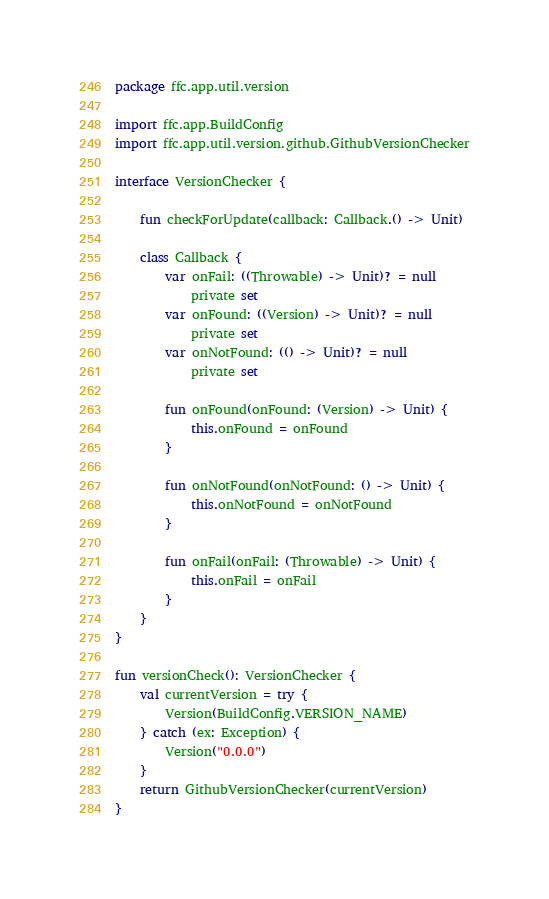<code> <loc_0><loc_0><loc_500><loc_500><_Kotlin_>package ffc.app.util.version

import ffc.app.BuildConfig
import ffc.app.util.version.github.GithubVersionChecker

interface VersionChecker {

    fun checkForUpdate(callback: Callback.() -> Unit)

    class Callback {
        var onFail: ((Throwable) -> Unit)? = null
            private set
        var onFound: ((Version) -> Unit)? = null
            private set
        var onNotFound: (() -> Unit)? = null
            private set

        fun onFound(onFound: (Version) -> Unit) {
            this.onFound = onFound
        }

        fun onNotFound(onNotFound: () -> Unit) {
            this.onNotFound = onNotFound
        }

        fun onFail(onFail: (Throwable) -> Unit) {
            this.onFail = onFail
        }
    }
}

fun versionCheck(): VersionChecker {
    val currentVersion = try {
        Version(BuildConfig.VERSION_NAME)
    } catch (ex: Exception) {
        Version("0.0.0")
    }
    return GithubVersionChecker(currentVersion)
}
</code> 